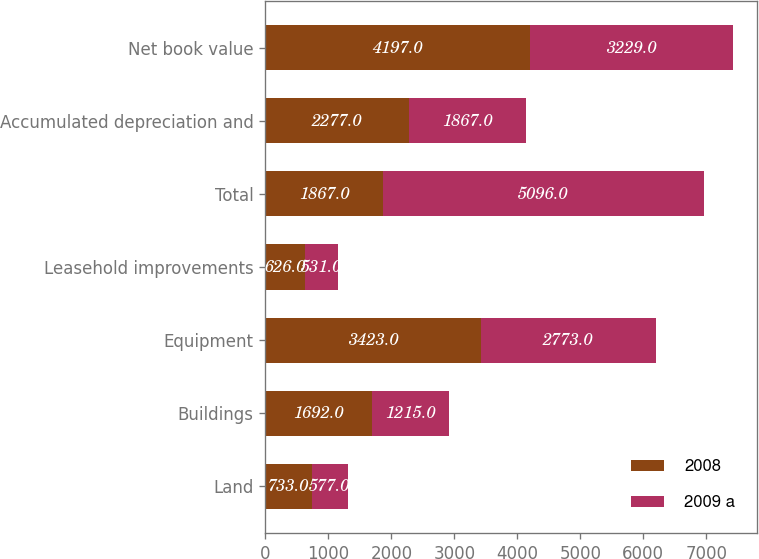<chart> <loc_0><loc_0><loc_500><loc_500><stacked_bar_chart><ecel><fcel>Land<fcel>Buildings<fcel>Equipment<fcel>Leasehold improvements<fcel>Total<fcel>Accumulated depreciation and<fcel>Net book value<nl><fcel>2008<fcel>733<fcel>1692<fcel>3423<fcel>626<fcel>1867<fcel>2277<fcel>4197<nl><fcel>2009 a<fcel>577<fcel>1215<fcel>2773<fcel>531<fcel>5096<fcel>1867<fcel>3229<nl></chart> 